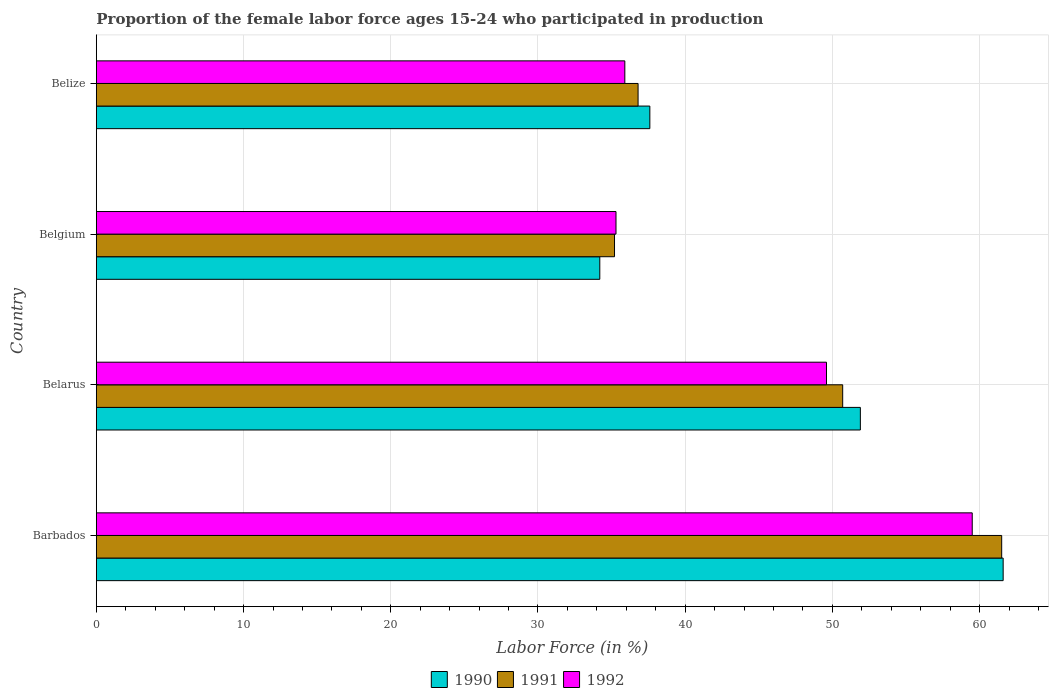How many different coloured bars are there?
Provide a succinct answer. 3. Are the number of bars on each tick of the Y-axis equal?
Your answer should be very brief. Yes. How many bars are there on the 4th tick from the top?
Your answer should be compact. 3. How many bars are there on the 1st tick from the bottom?
Your response must be concise. 3. What is the label of the 3rd group of bars from the top?
Make the answer very short. Belarus. In how many cases, is the number of bars for a given country not equal to the number of legend labels?
Ensure brevity in your answer.  0. What is the proportion of the female labor force who participated in production in 1990 in Belize?
Make the answer very short. 37.6. Across all countries, what is the maximum proportion of the female labor force who participated in production in 1990?
Your answer should be very brief. 61.6. Across all countries, what is the minimum proportion of the female labor force who participated in production in 1991?
Your answer should be compact. 35.2. In which country was the proportion of the female labor force who participated in production in 1992 maximum?
Ensure brevity in your answer.  Barbados. What is the total proportion of the female labor force who participated in production in 1990 in the graph?
Offer a very short reply. 185.3. What is the difference between the proportion of the female labor force who participated in production in 1991 in Barbados and that in Belarus?
Provide a succinct answer. 10.8. What is the difference between the proportion of the female labor force who participated in production in 1992 in Barbados and the proportion of the female labor force who participated in production in 1991 in Belgium?
Your response must be concise. 24.3. What is the average proportion of the female labor force who participated in production in 1991 per country?
Keep it short and to the point. 46.05. What is the difference between the proportion of the female labor force who participated in production in 1990 and proportion of the female labor force who participated in production in 1991 in Belarus?
Provide a succinct answer. 1.2. What is the ratio of the proportion of the female labor force who participated in production in 1990 in Barbados to that in Belize?
Give a very brief answer. 1.64. Is the proportion of the female labor force who participated in production in 1992 in Belgium less than that in Belize?
Make the answer very short. Yes. What is the difference between the highest and the second highest proportion of the female labor force who participated in production in 1991?
Provide a short and direct response. 10.8. What is the difference between the highest and the lowest proportion of the female labor force who participated in production in 1992?
Provide a succinct answer. 24.2. In how many countries, is the proportion of the female labor force who participated in production in 1991 greater than the average proportion of the female labor force who participated in production in 1991 taken over all countries?
Provide a short and direct response. 2. Is the sum of the proportion of the female labor force who participated in production in 1992 in Barbados and Belarus greater than the maximum proportion of the female labor force who participated in production in 1991 across all countries?
Your answer should be very brief. Yes. How many bars are there?
Your answer should be compact. 12. Are all the bars in the graph horizontal?
Provide a succinct answer. Yes. What is the difference between two consecutive major ticks on the X-axis?
Keep it short and to the point. 10. Where does the legend appear in the graph?
Your answer should be compact. Bottom center. How are the legend labels stacked?
Your response must be concise. Horizontal. What is the title of the graph?
Your response must be concise. Proportion of the female labor force ages 15-24 who participated in production. What is the Labor Force (in %) in 1990 in Barbados?
Your response must be concise. 61.6. What is the Labor Force (in %) of 1991 in Barbados?
Ensure brevity in your answer.  61.5. What is the Labor Force (in %) in 1992 in Barbados?
Your response must be concise. 59.5. What is the Labor Force (in %) of 1990 in Belarus?
Provide a short and direct response. 51.9. What is the Labor Force (in %) of 1991 in Belarus?
Provide a short and direct response. 50.7. What is the Labor Force (in %) of 1992 in Belarus?
Provide a succinct answer. 49.6. What is the Labor Force (in %) of 1990 in Belgium?
Ensure brevity in your answer.  34.2. What is the Labor Force (in %) in 1991 in Belgium?
Offer a terse response. 35.2. What is the Labor Force (in %) of 1992 in Belgium?
Your answer should be very brief. 35.3. What is the Labor Force (in %) in 1990 in Belize?
Provide a short and direct response. 37.6. What is the Labor Force (in %) in 1991 in Belize?
Your response must be concise. 36.8. What is the Labor Force (in %) of 1992 in Belize?
Provide a short and direct response. 35.9. Across all countries, what is the maximum Labor Force (in %) of 1990?
Provide a short and direct response. 61.6. Across all countries, what is the maximum Labor Force (in %) in 1991?
Provide a succinct answer. 61.5. Across all countries, what is the maximum Labor Force (in %) of 1992?
Keep it short and to the point. 59.5. Across all countries, what is the minimum Labor Force (in %) in 1990?
Ensure brevity in your answer.  34.2. Across all countries, what is the minimum Labor Force (in %) of 1991?
Your answer should be compact. 35.2. Across all countries, what is the minimum Labor Force (in %) of 1992?
Offer a terse response. 35.3. What is the total Labor Force (in %) in 1990 in the graph?
Provide a succinct answer. 185.3. What is the total Labor Force (in %) in 1991 in the graph?
Your response must be concise. 184.2. What is the total Labor Force (in %) of 1992 in the graph?
Provide a succinct answer. 180.3. What is the difference between the Labor Force (in %) of 1992 in Barbados and that in Belarus?
Provide a succinct answer. 9.9. What is the difference between the Labor Force (in %) of 1990 in Barbados and that in Belgium?
Your answer should be compact. 27.4. What is the difference between the Labor Force (in %) in 1991 in Barbados and that in Belgium?
Give a very brief answer. 26.3. What is the difference between the Labor Force (in %) of 1992 in Barbados and that in Belgium?
Give a very brief answer. 24.2. What is the difference between the Labor Force (in %) of 1990 in Barbados and that in Belize?
Your answer should be very brief. 24. What is the difference between the Labor Force (in %) in 1991 in Barbados and that in Belize?
Provide a succinct answer. 24.7. What is the difference between the Labor Force (in %) of 1992 in Barbados and that in Belize?
Your answer should be very brief. 23.6. What is the difference between the Labor Force (in %) of 1990 in Belarus and that in Belgium?
Offer a very short reply. 17.7. What is the difference between the Labor Force (in %) of 1991 in Belarus and that in Belgium?
Provide a short and direct response. 15.5. What is the difference between the Labor Force (in %) in 1992 in Belarus and that in Belgium?
Your response must be concise. 14.3. What is the difference between the Labor Force (in %) in 1990 in Belarus and that in Belize?
Ensure brevity in your answer.  14.3. What is the difference between the Labor Force (in %) of 1991 in Belarus and that in Belize?
Offer a very short reply. 13.9. What is the difference between the Labor Force (in %) in 1992 in Belarus and that in Belize?
Your answer should be compact. 13.7. What is the difference between the Labor Force (in %) in 1990 in Barbados and the Labor Force (in %) in 1991 in Belgium?
Give a very brief answer. 26.4. What is the difference between the Labor Force (in %) in 1990 in Barbados and the Labor Force (in %) in 1992 in Belgium?
Your answer should be compact. 26.3. What is the difference between the Labor Force (in %) of 1991 in Barbados and the Labor Force (in %) of 1992 in Belgium?
Your answer should be compact. 26.2. What is the difference between the Labor Force (in %) in 1990 in Barbados and the Labor Force (in %) in 1991 in Belize?
Keep it short and to the point. 24.8. What is the difference between the Labor Force (in %) of 1990 in Barbados and the Labor Force (in %) of 1992 in Belize?
Provide a succinct answer. 25.7. What is the difference between the Labor Force (in %) of 1991 in Barbados and the Labor Force (in %) of 1992 in Belize?
Make the answer very short. 25.6. What is the difference between the Labor Force (in %) of 1990 in Belarus and the Labor Force (in %) of 1991 in Belgium?
Offer a very short reply. 16.7. What is the difference between the Labor Force (in %) of 1990 in Belarus and the Labor Force (in %) of 1992 in Belgium?
Offer a terse response. 16.6. What is the difference between the Labor Force (in %) of 1991 in Belarus and the Labor Force (in %) of 1992 in Belize?
Give a very brief answer. 14.8. What is the difference between the Labor Force (in %) of 1990 in Belgium and the Labor Force (in %) of 1991 in Belize?
Ensure brevity in your answer.  -2.6. What is the average Labor Force (in %) of 1990 per country?
Offer a terse response. 46.33. What is the average Labor Force (in %) of 1991 per country?
Offer a very short reply. 46.05. What is the average Labor Force (in %) in 1992 per country?
Ensure brevity in your answer.  45.08. What is the difference between the Labor Force (in %) in 1990 and Labor Force (in %) in 1991 in Barbados?
Provide a short and direct response. 0.1. What is the difference between the Labor Force (in %) of 1991 and Labor Force (in %) of 1992 in Barbados?
Your answer should be very brief. 2. What is the difference between the Labor Force (in %) in 1990 and Labor Force (in %) in 1992 in Belarus?
Your answer should be very brief. 2.3. What is the difference between the Labor Force (in %) of 1991 and Labor Force (in %) of 1992 in Belarus?
Your answer should be compact. 1.1. What is the difference between the Labor Force (in %) of 1990 and Labor Force (in %) of 1991 in Belize?
Your answer should be compact. 0.8. What is the difference between the Labor Force (in %) in 1991 and Labor Force (in %) in 1992 in Belize?
Make the answer very short. 0.9. What is the ratio of the Labor Force (in %) in 1990 in Barbados to that in Belarus?
Your response must be concise. 1.19. What is the ratio of the Labor Force (in %) of 1991 in Barbados to that in Belarus?
Your answer should be very brief. 1.21. What is the ratio of the Labor Force (in %) of 1992 in Barbados to that in Belarus?
Your answer should be compact. 1.2. What is the ratio of the Labor Force (in %) in 1990 in Barbados to that in Belgium?
Make the answer very short. 1.8. What is the ratio of the Labor Force (in %) in 1991 in Barbados to that in Belgium?
Ensure brevity in your answer.  1.75. What is the ratio of the Labor Force (in %) of 1992 in Barbados to that in Belgium?
Offer a terse response. 1.69. What is the ratio of the Labor Force (in %) in 1990 in Barbados to that in Belize?
Keep it short and to the point. 1.64. What is the ratio of the Labor Force (in %) in 1991 in Barbados to that in Belize?
Your answer should be compact. 1.67. What is the ratio of the Labor Force (in %) in 1992 in Barbados to that in Belize?
Give a very brief answer. 1.66. What is the ratio of the Labor Force (in %) in 1990 in Belarus to that in Belgium?
Offer a terse response. 1.52. What is the ratio of the Labor Force (in %) of 1991 in Belarus to that in Belgium?
Provide a succinct answer. 1.44. What is the ratio of the Labor Force (in %) in 1992 in Belarus to that in Belgium?
Keep it short and to the point. 1.41. What is the ratio of the Labor Force (in %) of 1990 in Belarus to that in Belize?
Give a very brief answer. 1.38. What is the ratio of the Labor Force (in %) in 1991 in Belarus to that in Belize?
Offer a very short reply. 1.38. What is the ratio of the Labor Force (in %) in 1992 in Belarus to that in Belize?
Your answer should be very brief. 1.38. What is the ratio of the Labor Force (in %) of 1990 in Belgium to that in Belize?
Give a very brief answer. 0.91. What is the ratio of the Labor Force (in %) in 1991 in Belgium to that in Belize?
Keep it short and to the point. 0.96. What is the ratio of the Labor Force (in %) of 1992 in Belgium to that in Belize?
Make the answer very short. 0.98. What is the difference between the highest and the second highest Labor Force (in %) in 1992?
Your answer should be very brief. 9.9. What is the difference between the highest and the lowest Labor Force (in %) in 1990?
Provide a succinct answer. 27.4. What is the difference between the highest and the lowest Labor Force (in %) of 1991?
Provide a short and direct response. 26.3. What is the difference between the highest and the lowest Labor Force (in %) in 1992?
Make the answer very short. 24.2. 